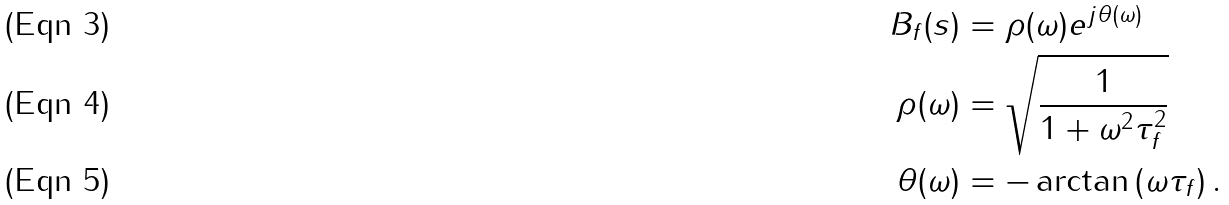<formula> <loc_0><loc_0><loc_500><loc_500>B _ { f } ( s ) & = \rho ( \omega ) e ^ { j \theta ( \omega ) } \\ \rho ( \omega ) & = \sqrt { \frac { 1 } { 1 + \omega ^ { 2 } \tau ^ { 2 } _ { f } } } \\ \theta ( \omega ) & = - \arctan \left ( \omega \tau _ { f } \right ) .</formula> 